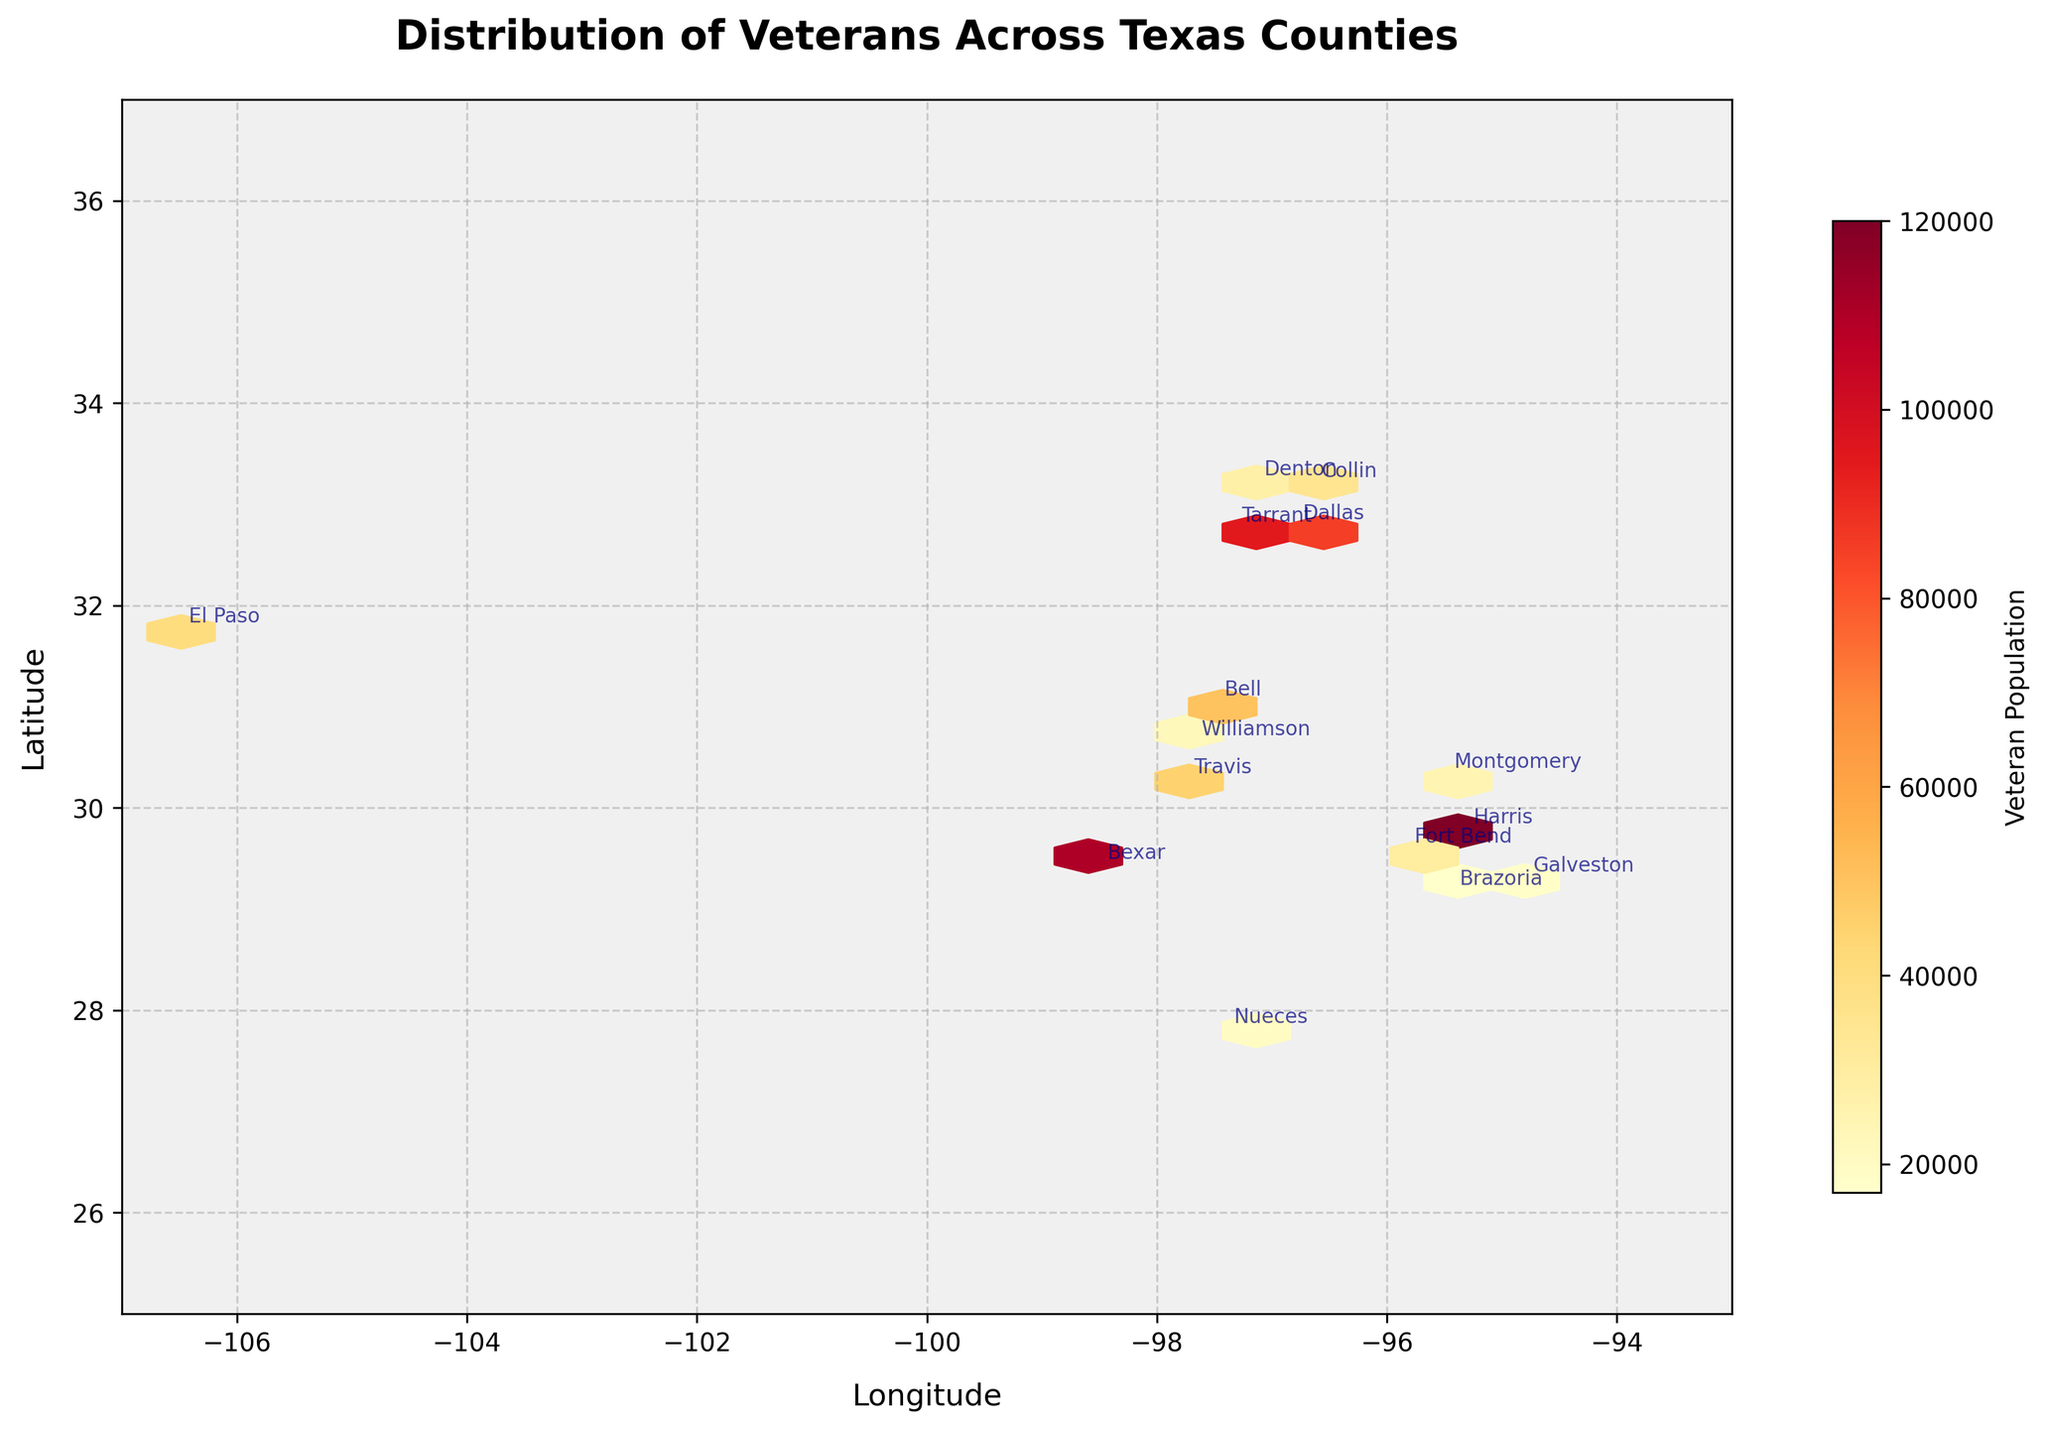What is the title of the hexbin plot? The title of the plot is shown at the top of the figure. It reads “Distribution of Veterans Across Texas Counties.”
Answer: Distribution of Veterans Across Texas Counties Which county has the highest veteran population according to the hexbin plot? The hexbin plot annotates each county, and you can see that Harris County has the highest veteran population, indicated by a larger concentration of color in that area.
Answer: Harris How is the color gradient used to represent the veteran population in the hexbin plot? The color gradient ranges from lighter to darker shades. In this plot, ‘YlOrRd’ color scheme is used where lighter yellow represents lower veteran populations and darker red indicates higher veteran populations.
Answer: Lighter to darker shades Which two counties have the smallest veteran populations, and what are their values? The annotations for each county show veteran populations. The smallest veteran populations appear to be in Galveston County (18,000) and Brazoria County (17,000).
Answer: Galveston (18,000) and Brazoria (17,000) Compare the veteran populations of Bexar County and Tarrant County. Which has more veterans, and by how much? Bexar County has 110,000 veterans, whereas Tarrant County has 95,000 veterans. Subtract Tarrant's population from Bexar's to find the difference: 110,000 - 95,000 = 15,000.
Answer: Bexar, by 15,000 What is the range of latitude covered in the hexbin plot? The latitude axis ranges from the lower limit of 25 to the upper limit of 37 according to the y-axis labels on the plot.
Answer: 25 to 37 What does the colorbar represent in the hexbin plot? The colorbar to the right of the plot indicates the veteran population, as it's labeled "Veteran Population." The gradient shows different population densities.
Answer: Veteran Population Approximately how many veterans are found in the urban areas of Texas according to the plot? Urban areas show a higher concentration of darker hexagons, particularly in larger metropolitan areas like Harris, Bexar, Dallas, and Tarrant counties. Summing up their veteran populations: 120,000 (Harris) + 110,000 (Bexar) + 85,000 (Dallas) + 95,000 (Tarrant) = 410,000.
Answer: 410,000 How does the veteran population in El Paso County compare to that of Bell County? El Paso County has 40,000 veterans while Bell County has 50,000 veterans. Bell County thus has 10,000 more veterans than El Paso.
Answer: Bell has 10,000 more than El Paso 